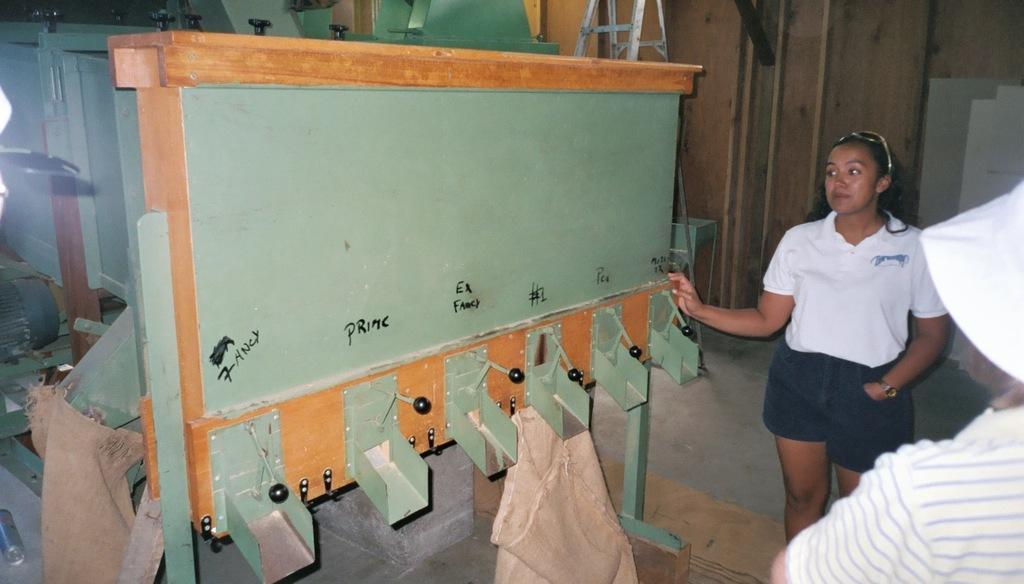Could you give a brief overview of what you see in this image? In this picture I can see two persons, there is a ladder, there are grinders, there are two woven bags. 